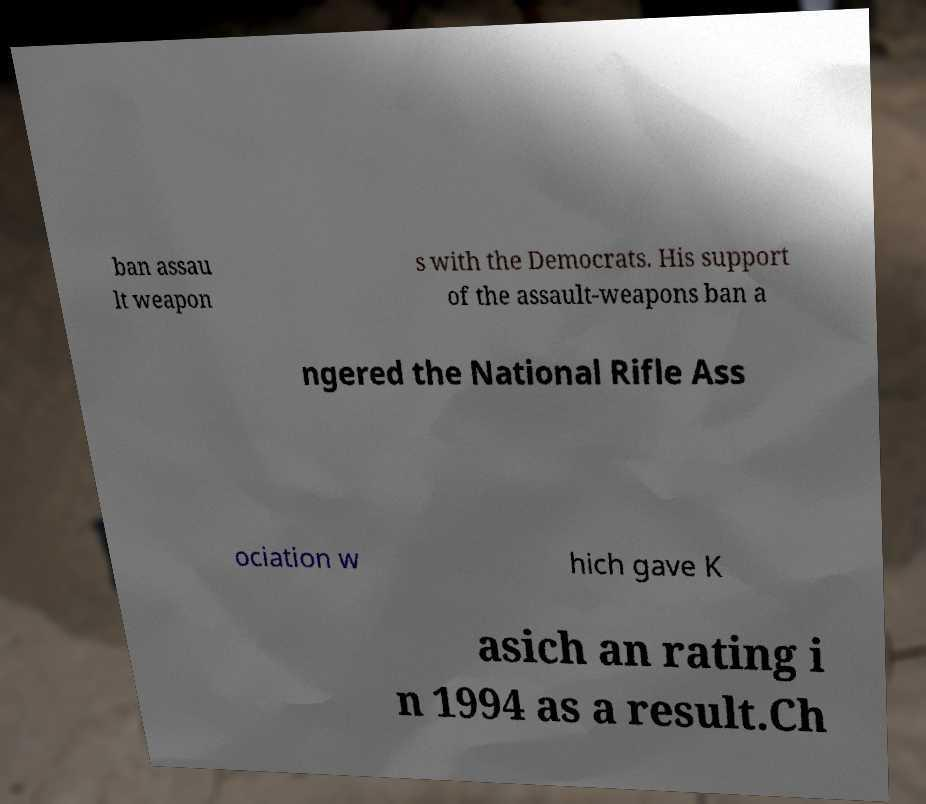There's text embedded in this image that I need extracted. Can you transcribe it verbatim? ban assau lt weapon s with the Democrats. His support of the assault-weapons ban a ngered the National Rifle Ass ociation w hich gave K asich an rating i n 1994 as a result.Ch 